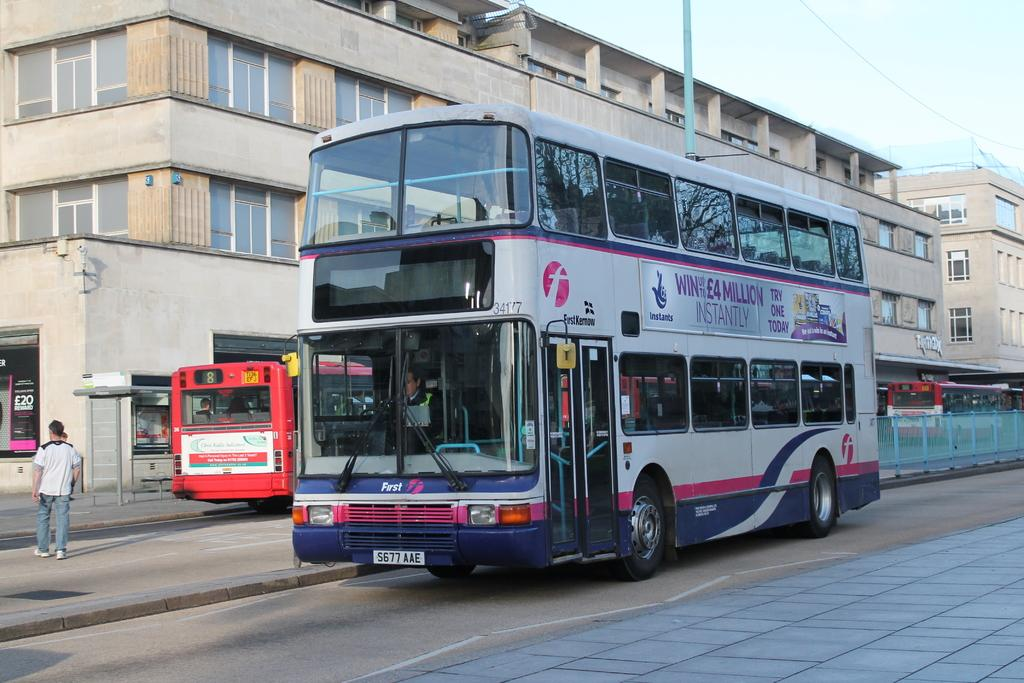What is the main subject in the center of the image? There is a bus in the center of the image. Where is the bus located? The bus is on the road. What can be seen in the background of the image? There is a building in the background of the image. Is there any human activity visible in the image? Yes, there is a person walking to the left side of the image. What type of skate is being used by the person walking in the image? There is no skate present in the image; the person is walking. Can you tell me the stem of the plant that is growing next to the bus? There is no plant or stem visible in the image; it only features a bus, a road, a building, and a person walking. 